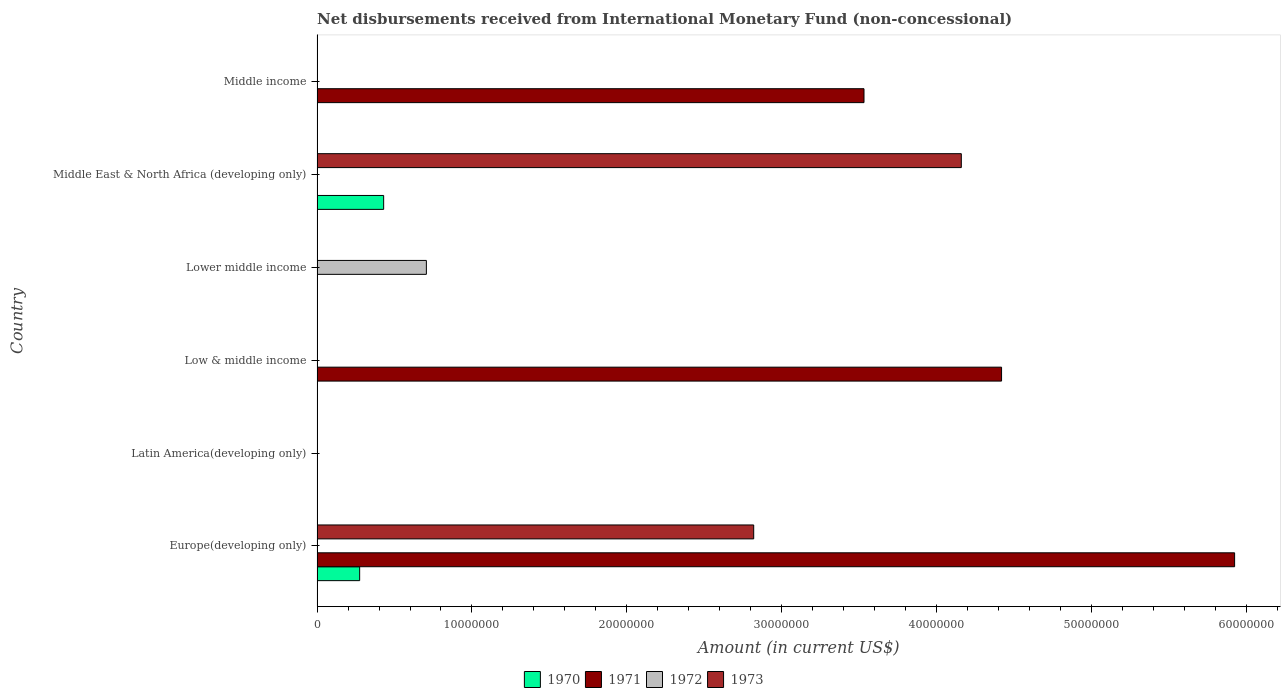Are the number of bars on each tick of the Y-axis equal?
Your answer should be very brief. No. How many bars are there on the 1st tick from the bottom?
Give a very brief answer. 3. What is the label of the 5th group of bars from the top?
Keep it short and to the point. Latin America(developing only). What is the amount of disbursements received from International Monetary Fund in 1973 in Europe(developing only)?
Offer a very short reply. 2.82e+07. Across all countries, what is the maximum amount of disbursements received from International Monetary Fund in 1973?
Provide a succinct answer. 4.16e+07. In which country was the amount of disbursements received from International Monetary Fund in 1973 maximum?
Your answer should be compact. Middle East & North Africa (developing only). What is the total amount of disbursements received from International Monetary Fund in 1970 in the graph?
Provide a succinct answer. 7.05e+06. What is the difference between the amount of disbursements received from International Monetary Fund in 1971 in Europe(developing only) and that in Middle income?
Your answer should be very brief. 2.39e+07. What is the average amount of disbursements received from International Monetary Fund in 1970 per country?
Your response must be concise. 1.18e+06. What is the difference between the highest and the second highest amount of disbursements received from International Monetary Fund in 1971?
Your answer should be very brief. 1.50e+07. What is the difference between the highest and the lowest amount of disbursements received from International Monetary Fund in 1973?
Offer a terse response. 4.16e+07. In how many countries, is the amount of disbursements received from International Monetary Fund in 1973 greater than the average amount of disbursements received from International Monetary Fund in 1973 taken over all countries?
Keep it short and to the point. 2. Is it the case that in every country, the sum of the amount of disbursements received from International Monetary Fund in 1970 and amount of disbursements received from International Monetary Fund in 1972 is greater than the sum of amount of disbursements received from International Monetary Fund in 1971 and amount of disbursements received from International Monetary Fund in 1973?
Make the answer very short. No. Is it the case that in every country, the sum of the amount of disbursements received from International Monetary Fund in 1973 and amount of disbursements received from International Monetary Fund in 1971 is greater than the amount of disbursements received from International Monetary Fund in 1972?
Make the answer very short. No. How many countries are there in the graph?
Offer a terse response. 6. Where does the legend appear in the graph?
Ensure brevity in your answer.  Bottom center. What is the title of the graph?
Provide a succinct answer. Net disbursements received from International Monetary Fund (non-concessional). Does "1988" appear as one of the legend labels in the graph?
Provide a succinct answer. No. What is the label or title of the Y-axis?
Offer a very short reply. Country. What is the Amount (in current US$) in 1970 in Europe(developing only)?
Keep it short and to the point. 2.75e+06. What is the Amount (in current US$) of 1971 in Europe(developing only)?
Offer a very short reply. 5.92e+07. What is the Amount (in current US$) of 1973 in Europe(developing only)?
Provide a succinct answer. 2.82e+07. What is the Amount (in current US$) in 1970 in Latin America(developing only)?
Provide a short and direct response. 0. What is the Amount (in current US$) in 1971 in Latin America(developing only)?
Your answer should be compact. 0. What is the Amount (in current US$) of 1973 in Latin America(developing only)?
Provide a short and direct response. 0. What is the Amount (in current US$) of 1971 in Low & middle income?
Give a very brief answer. 4.42e+07. What is the Amount (in current US$) in 1972 in Low & middle income?
Your response must be concise. 0. What is the Amount (in current US$) in 1971 in Lower middle income?
Give a very brief answer. 0. What is the Amount (in current US$) of 1972 in Lower middle income?
Ensure brevity in your answer.  7.06e+06. What is the Amount (in current US$) of 1973 in Lower middle income?
Keep it short and to the point. 0. What is the Amount (in current US$) of 1970 in Middle East & North Africa (developing only)?
Your answer should be very brief. 4.30e+06. What is the Amount (in current US$) of 1972 in Middle East & North Africa (developing only)?
Offer a very short reply. 0. What is the Amount (in current US$) of 1973 in Middle East & North Africa (developing only)?
Your answer should be compact. 4.16e+07. What is the Amount (in current US$) in 1970 in Middle income?
Give a very brief answer. 0. What is the Amount (in current US$) in 1971 in Middle income?
Offer a very short reply. 3.53e+07. What is the Amount (in current US$) in 1972 in Middle income?
Provide a short and direct response. 0. What is the Amount (in current US$) of 1973 in Middle income?
Make the answer very short. 0. Across all countries, what is the maximum Amount (in current US$) of 1970?
Your answer should be very brief. 4.30e+06. Across all countries, what is the maximum Amount (in current US$) in 1971?
Your answer should be very brief. 5.92e+07. Across all countries, what is the maximum Amount (in current US$) in 1972?
Provide a succinct answer. 7.06e+06. Across all countries, what is the maximum Amount (in current US$) in 1973?
Keep it short and to the point. 4.16e+07. Across all countries, what is the minimum Amount (in current US$) of 1971?
Your response must be concise. 0. Across all countries, what is the minimum Amount (in current US$) of 1973?
Provide a short and direct response. 0. What is the total Amount (in current US$) in 1970 in the graph?
Your answer should be very brief. 7.05e+06. What is the total Amount (in current US$) of 1971 in the graph?
Your answer should be compact. 1.39e+08. What is the total Amount (in current US$) in 1972 in the graph?
Provide a short and direct response. 7.06e+06. What is the total Amount (in current US$) of 1973 in the graph?
Ensure brevity in your answer.  6.98e+07. What is the difference between the Amount (in current US$) in 1971 in Europe(developing only) and that in Low & middle income?
Ensure brevity in your answer.  1.50e+07. What is the difference between the Amount (in current US$) of 1970 in Europe(developing only) and that in Middle East & North Africa (developing only)?
Make the answer very short. -1.55e+06. What is the difference between the Amount (in current US$) of 1973 in Europe(developing only) and that in Middle East & North Africa (developing only)?
Provide a short and direct response. -1.34e+07. What is the difference between the Amount (in current US$) in 1971 in Europe(developing only) and that in Middle income?
Ensure brevity in your answer.  2.39e+07. What is the difference between the Amount (in current US$) of 1971 in Low & middle income and that in Middle income?
Ensure brevity in your answer.  8.88e+06. What is the difference between the Amount (in current US$) of 1970 in Europe(developing only) and the Amount (in current US$) of 1971 in Low & middle income?
Your answer should be compact. -4.14e+07. What is the difference between the Amount (in current US$) in 1970 in Europe(developing only) and the Amount (in current US$) in 1972 in Lower middle income?
Your response must be concise. -4.31e+06. What is the difference between the Amount (in current US$) in 1971 in Europe(developing only) and the Amount (in current US$) in 1972 in Lower middle income?
Ensure brevity in your answer.  5.22e+07. What is the difference between the Amount (in current US$) in 1970 in Europe(developing only) and the Amount (in current US$) in 1973 in Middle East & North Africa (developing only)?
Give a very brief answer. -3.88e+07. What is the difference between the Amount (in current US$) of 1971 in Europe(developing only) and the Amount (in current US$) of 1973 in Middle East & North Africa (developing only)?
Offer a terse response. 1.76e+07. What is the difference between the Amount (in current US$) in 1970 in Europe(developing only) and the Amount (in current US$) in 1971 in Middle income?
Your answer should be very brief. -3.26e+07. What is the difference between the Amount (in current US$) in 1971 in Low & middle income and the Amount (in current US$) in 1972 in Lower middle income?
Your answer should be compact. 3.71e+07. What is the difference between the Amount (in current US$) of 1971 in Low & middle income and the Amount (in current US$) of 1973 in Middle East & North Africa (developing only)?
Your response must be concise. 2.60e+06. What is the difference between the Amount (in current US$) of 1972 in Lower middle income and the Amount (in current US$) of 1973 in Middle East & North Africa (developing only)?
Your answer should be very brief. -3.45e+07. What is the difference between the Amount (in current US$) in 1970 in Middle East & North Africa (developing only) and the Amount (in current US$) in 1971 in Middle income?
Your response must be concise. -3.10e+07. What is the average Amount (in current US$) in 1970 per country?
Offer a very short reply. 1.18e+06. What is the average Amount (in current US$) of 1971 per country?
Give a very brief answer. 2.31e+07. What is the average Amount (in current US$) of 1972 per country?
Offer a terse response. 1.18e+06. What is the average Amount (in current US$) of 1973 per country?
Offer a very short reply. 1.16e+07. What is the difference between the Amount (in current US$) in 1970 and Amount (in current US$) in 1971 in Europe(developing only)?
Offer a terse response. -5.65e+07. What is the difference between the Amount (in current US$) in 1970 and Amount (in current US$) in 1973 in Europe(developing only)?
Your answer should be very brief. -2.54e+07. What is the difference between the Amount (in current US$) in 1971 and Amount (in current US$) in 1973 in Europe(developing only)?
Give a very brief answer. 3.10e+07. What is the difference between the Amount (in current US$) of 1970 and Amount (in current US$) of 1973 in Middle East & North Africa (developing only)?
Your answer should be compact. -3.73e+07. What is the ratio of the Amount (in current US$) in 1971 in Europe(developing only) to that in Low & middle income?
Your response must be concise. 1.34. What is the ratio of the Amount (in current US$) in 1970 in Europe(developing only) to that in Middle East & North Africa (developing only)?
Your answer should be very brief. 0.64. What is the ratio of the Amount (in current US$) in 1973 in Europe(developing only) to that in Middle East & North Africa (developing only)?
Ensure brevity in your answer.  0.68. What is the ratio of the Amount (in current US$) in 1971 in Europe(developing only) to that in Middle income?
Provide a succinct answer. 1.68. What is the ratio of the Amount (in current US$) in 1971 in Low & middle income to that in Middle income?
Provide a succinct answer. 1.25. What is the difference between the highest and the second highest Amount (in current US$) of 1971?
Provide a succinct answer. 1.50e+07. What is the difference between the highest and the lowest Amount (in current US$) of 1970?
Keep it short and to the point. 4.30e+06. What is the difference between the highest and the lowest Amount (in current US$) of 1971?
Offer a terse response. 5.92e+07. What is the difference between the highest and the lowest Amount (in current US$) in 1972?
Offer a terse response. 7.06e+06. What is the difference between the highest and the lowest Amount (in current US$) in 1973?
Give a very brief answer. 4.16e+07. 